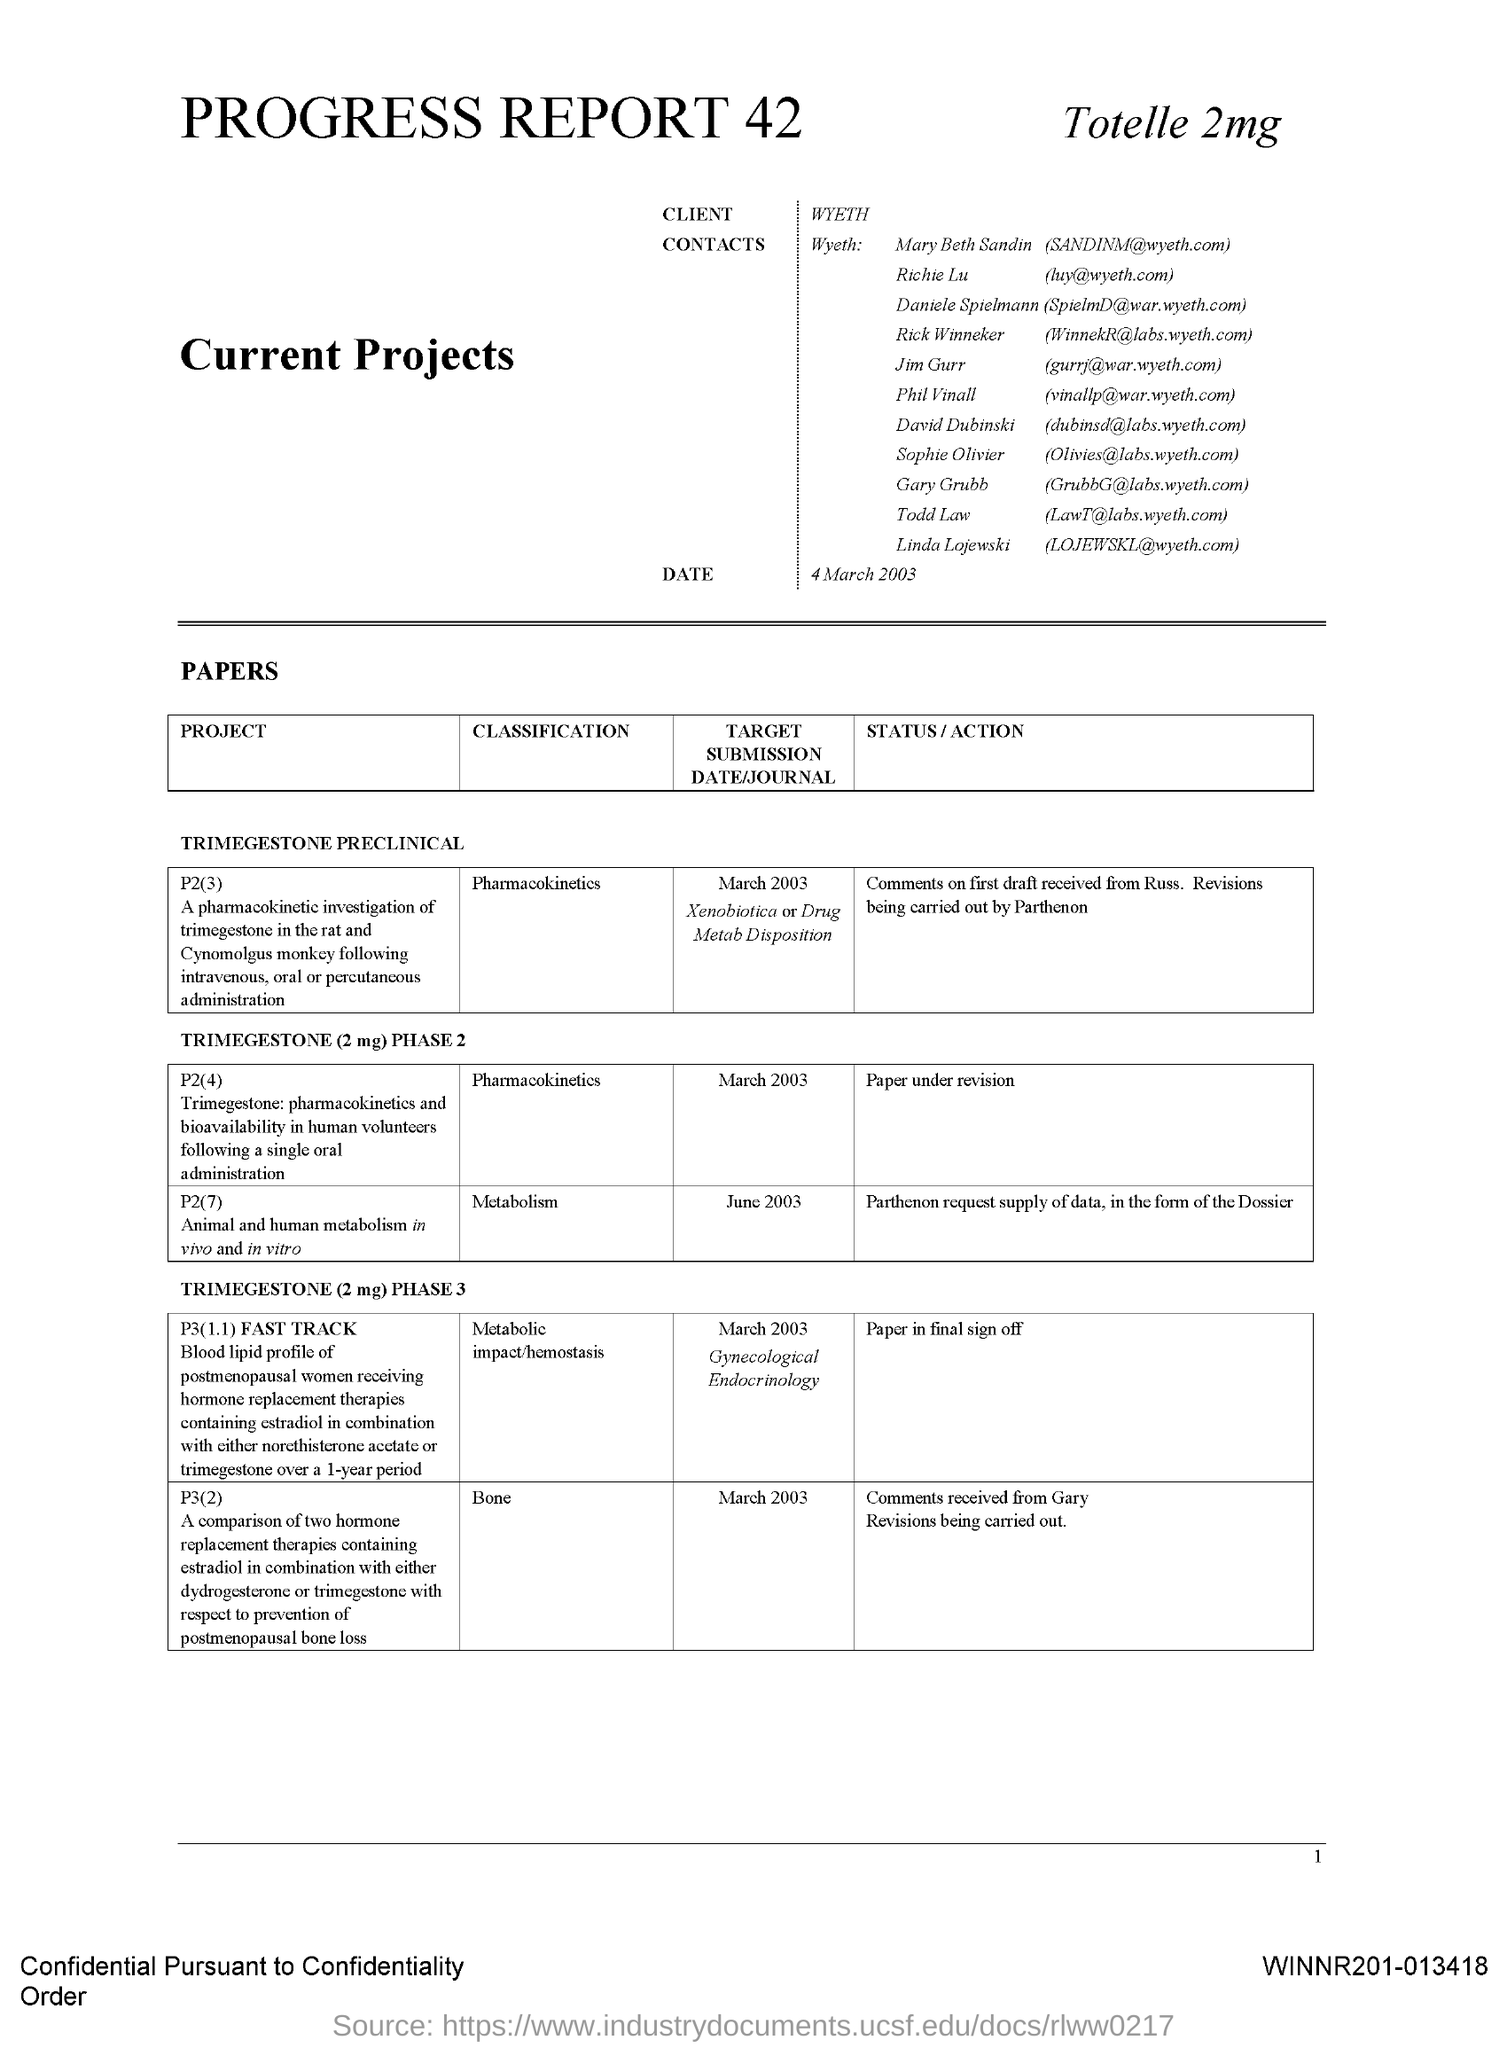Specify some key components in this picture. The client name mentioned in this document is Wyeth. 